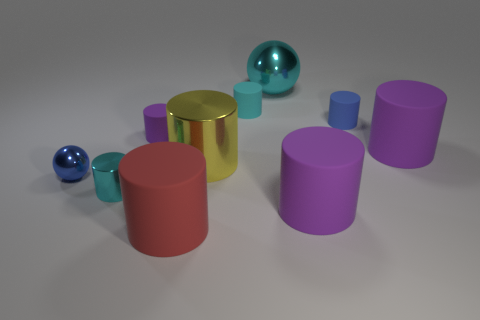What is the size of the red matte cylinder?
Offer a very short reply. Large. The large thing that is the same color as the tiny shiny cylinder is what shape?
Your answer should be very brief. Sphere. Are there more red objects than metallic things?
Your answer should be very brief. No. There is a ball to the left of the big thing that is behind the tiny matte thing that is on the right side of the big cyan thing; what color is it?
Make the answer very short. Blue. Is the shape of the large purple rubber thing that is in front of the tiny ball the same as  the large yellow object?
Make the answer very short. Yes. There is a metallic thing that is the same size as the blue sphere; what color is it?
Your answer should be compact. Cyan. What number of big metal cylinders are there?
Make the answer very short. 1. Do the purple object that is to the left of the big cyan object and the big cyan sphere have the same material?
Offer a terse response. No. What is the tiny cylinder that is behind the cyan metal cylinder and in front of the tiny blue rubber cylinder made of?
Offer a very short reply. Rubber. What size is the rubber cylinder that is the same color as the big shiny sphere?
Provide a succinct answer. Small. 